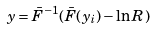<formula> <loc_0><loc_0><loc_500><loc_500>y = \bar { F } ^ { - 1 } ( \bar { F } ( y _ { i } ) - \ln R )</formula> 